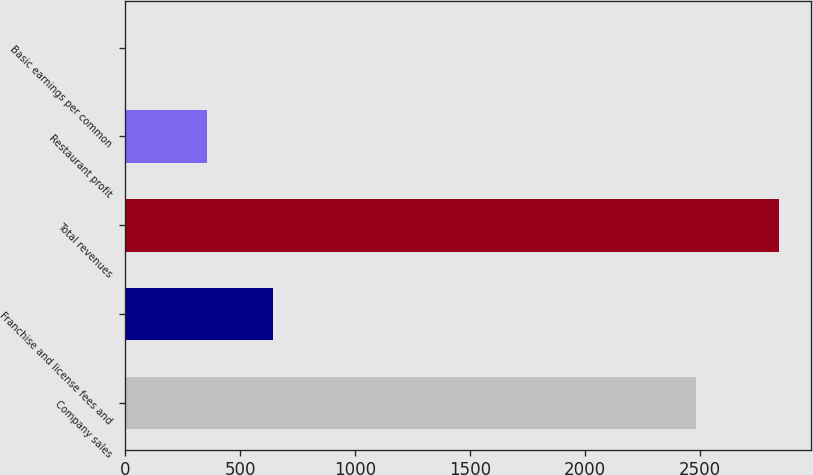<chart> <loc_0><loc_0><loc_500><loc_500><bar_chart><fcel>Company sales<fcel>Franchise and license fees and<fcel>Total revenues<fcel>Restaurant profit<fcel>Basic earnings per common<nl><fcel>2482<fcel>642.14<fcel>2842<fcel>358<fcel>0.6<nl></chart> 